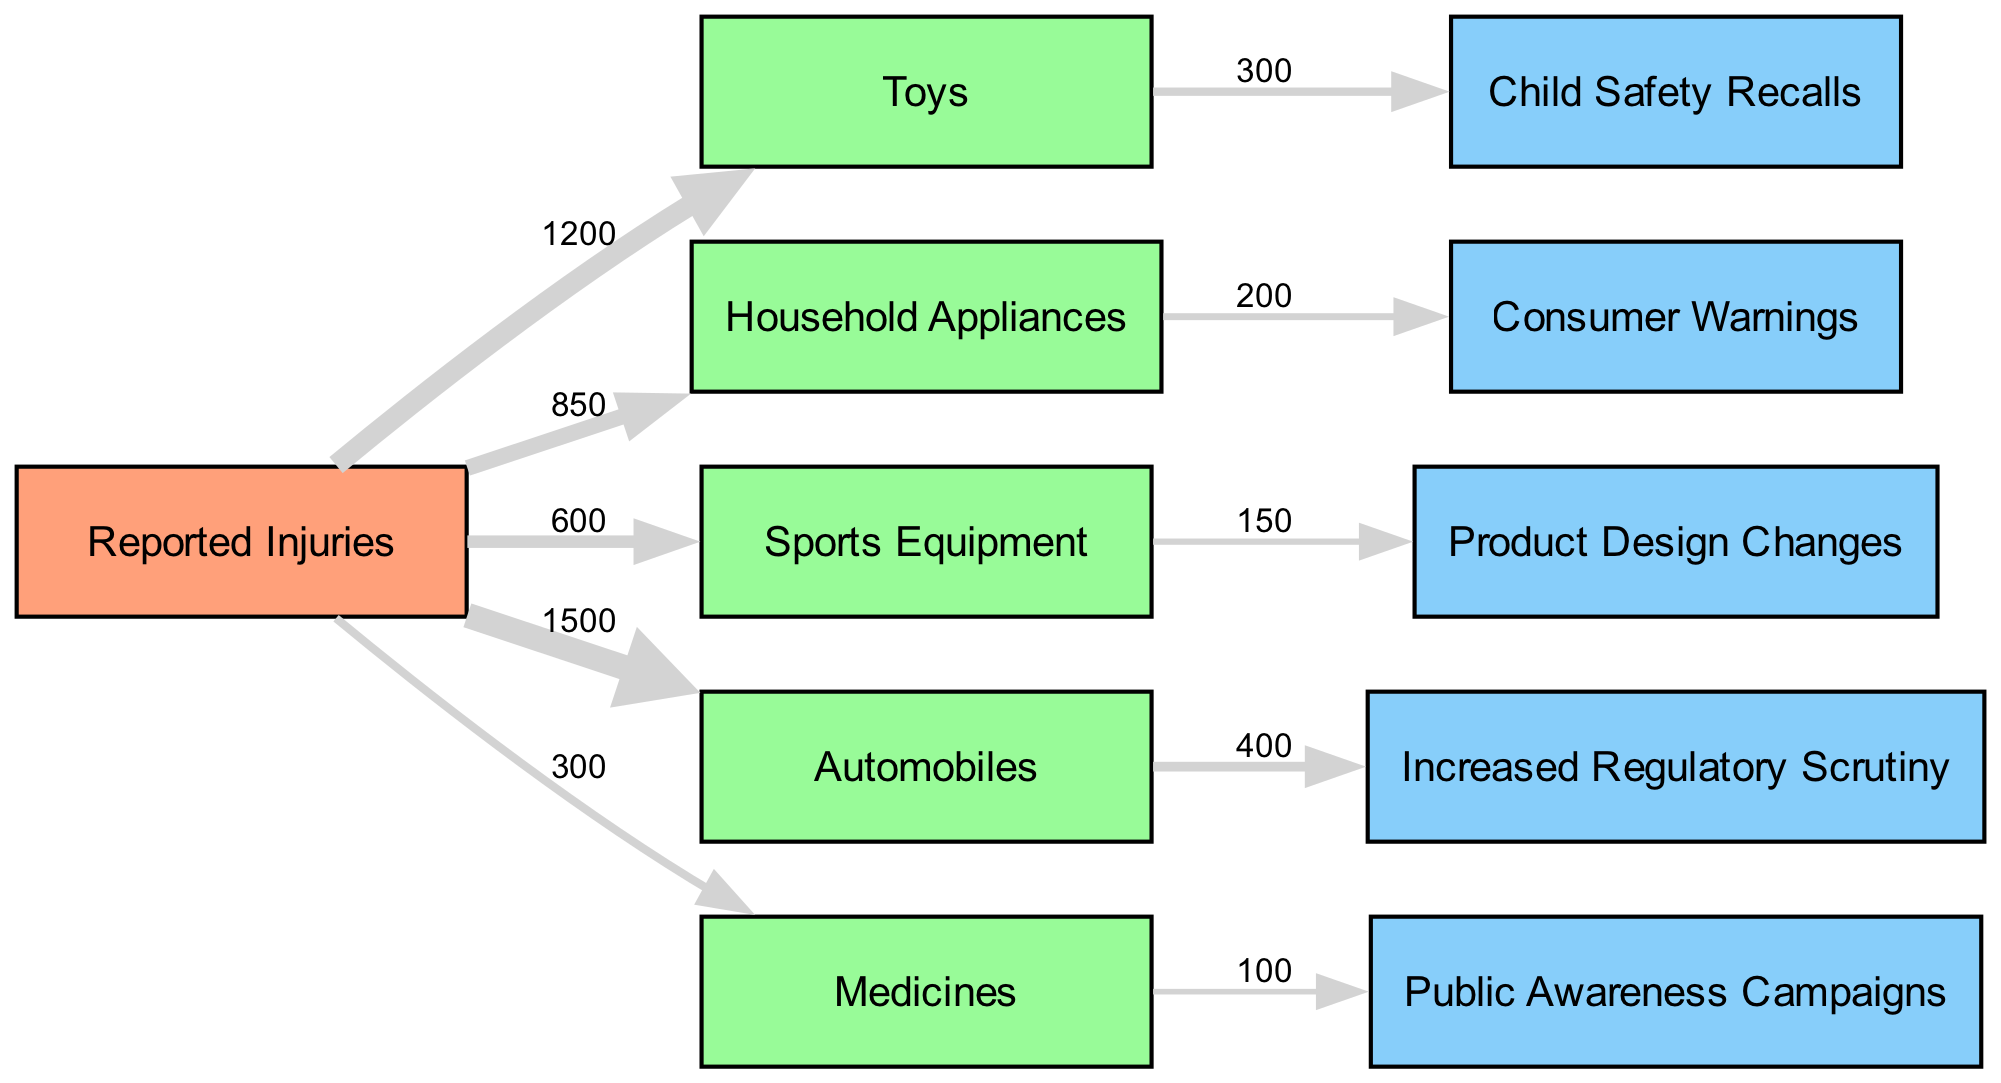What is the total number of reported injuries for products? To find the total number of reported injuries, we sum the values from all product sources: 1200 (Toys) + 850 (Household Appliances) + 600 (Sports Equipment) + 1500 (Automobiles) + 300 (Medicines) = 3450.
Answer: 3450 Which product type has the highest reported injuries? By analyzing the nodes for reported injuries, we see the following values: 1200 for Toys, 850 for Household Appliances, 600 for Sports Equipment, 1500 for Automobiles, and 300 for Medicines. The highest value is 1500 for Automobiles.
Answer: Automobiles How many response actions were taken for Toys? The diagram shows that there was one response action taken for Toys, which is Child Safety Recalls, with a value of 300.
Answer: 300 What is the value of increased regulatory scrutiny for Automobiles? The link directly leads from Automobiles to Increased Regulatory Scrutiny with a value of 400, indicating the number of reported injuries requiring this response action.
Answer: 400 Which product type received consumer warnings and how many injuries were reported? The link shows that Household Appliances received Consumer Warnings, with a total of 200 reported injuries. This can be directly observed in the link from Household Appliances to Consumer Warnings.
Answer: 200 Which response action has the lowest number linked to it? By reviewing the values linked to each response action, we identify that Public Awareness Campaigns has the lowest value at 100, as reflected by the link from Medicines.
Answer: 100 What percentage of reported injuries for Sports Equipment led to product design changes? For Sports Equipment, there are 600 reported injuries, and 150 of those resulted in Product Design Changes. To find the percentage, we calculate (150 / 600) * 100 = 25%.
Answer: 25% What total number of injuries corresponds to Child Safety Recalls? The diagram indicates that Child Safety Recalls emerged from Toys, which accounted for 300 reported injuries leading to that specific response action. Thus, the total is 300.
Answer: 300 How many products have a response action associated with them? Listing the products:
Toys (Child Safety Recalls), Household Appliances (Consumer Warnings), Sports Equipment (Product Design Changes), Automobiles (Increased Regulatory Scrutiny), and Medicines (Public Awareness Campaigns) shows all five have some form of action related. Therefore, the total is five products.
Answer: 5 